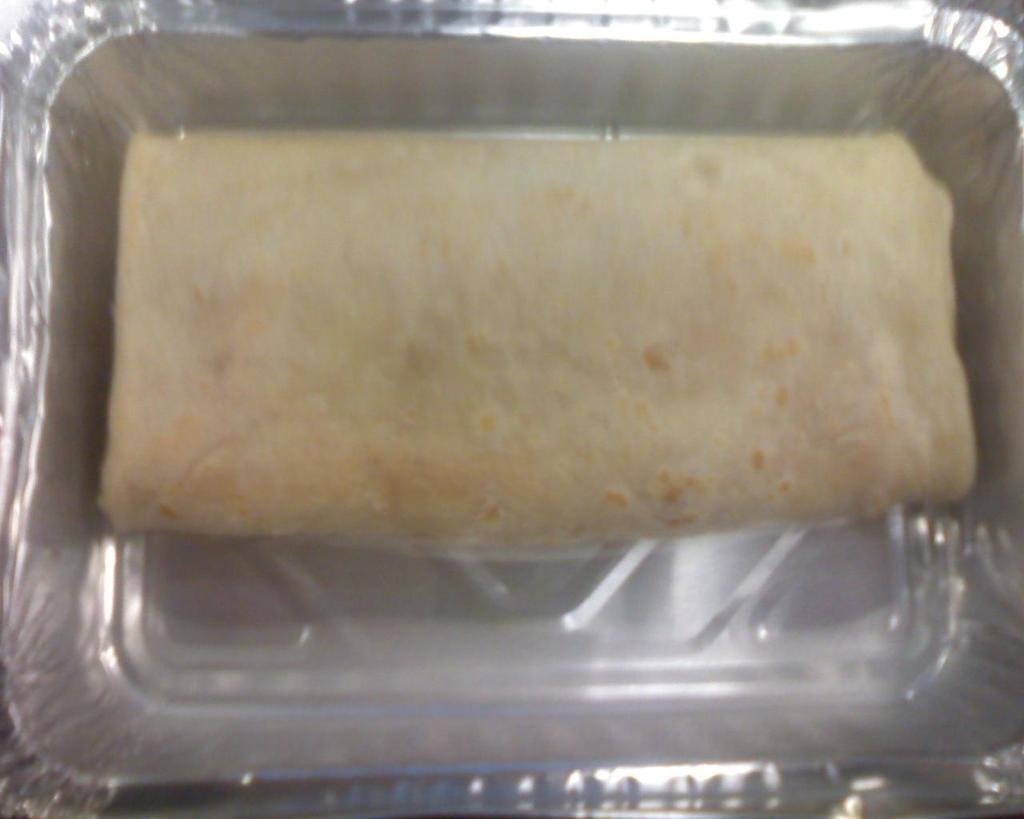What is the main subject of the image? There is a food item in the image. How is the food item contained or packaged? The food item is in a silver-colored box. What type of lead can be seen in the image? There is no lead present in the image; it features a food item in a silver-colored box. 